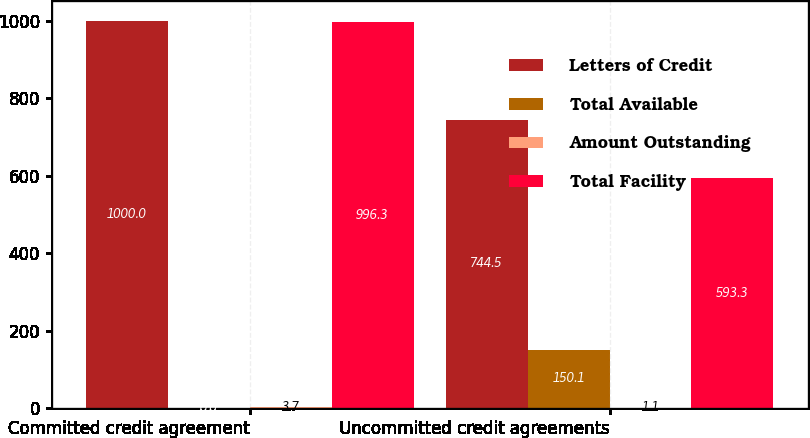<chart> <loc_0><loc_0><loc_500><loc_500><stacked_bar_chart><ecel><fcel>Committed credit agreement<fcel>Uncommitted credit agreements<nl><fcel>Letters of Credit<fcel>1000<fcel>744.5<nl><fcel>Total Available<fcel>0<fcel>150.1<nl><fcel>Amount Outstanding<fcel>3.7<fcel>1.1<nl><fcel>Total Facility<fcel>996.3<fcel>593.3<nl></chart> 